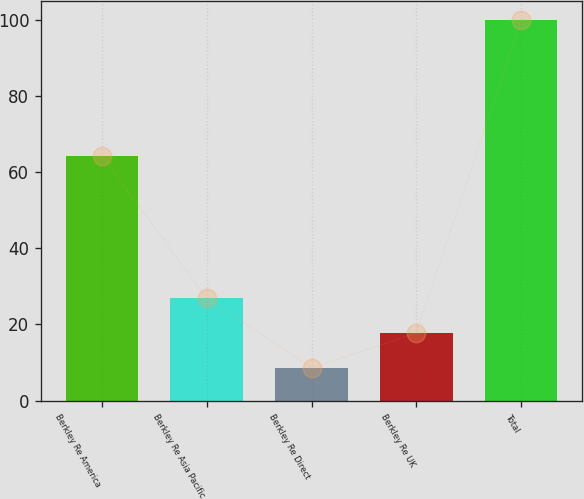<chart> <loc_0><loc_0><loc_500><loc_500><bar_chart><fcel>Berkley Re America<fcel>Berkley Re Asia Pacific<fcel>Berkley Re Direct<fcel>Berkley Re UK<fcel>Total<nl><fcel>64.2<fcel>26.88<fcel>8.6<fcel>17.74<fcel>100<nl></chart> 